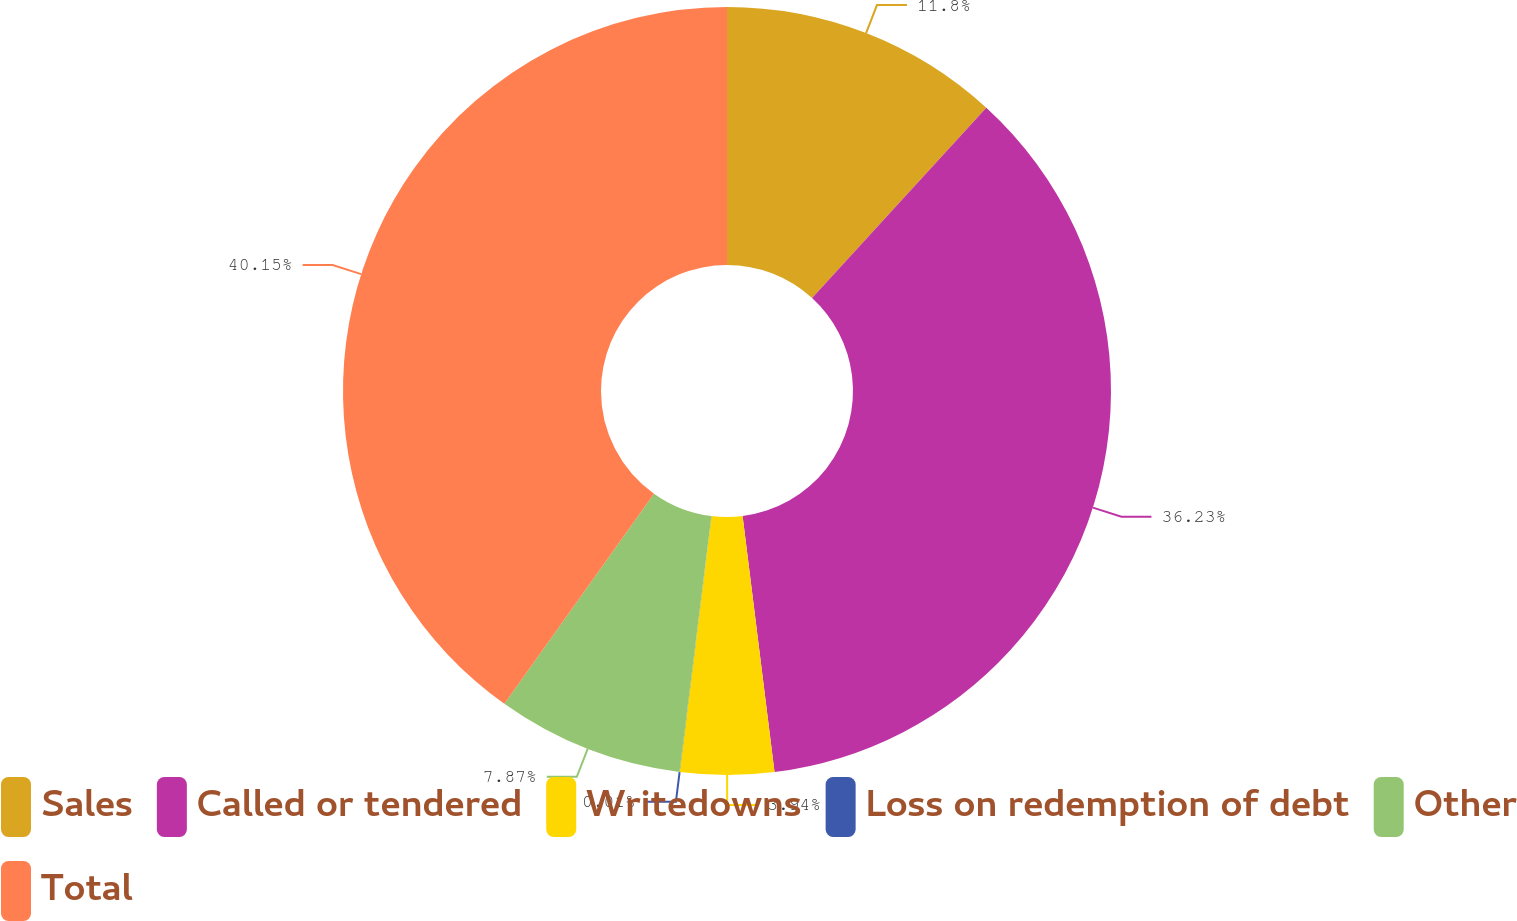Convert chart to OTSL. <chart><loc_0><loc_0><loc_500><loc_500><pie_chart><fcel>Sales<fcel>Called or tendered<fcel>Writedowns<fcel>Loss on redemption of debt<fcel>Other<fcel>Total<nl><fcel>11.8%<fcel>36.23%<fcel>3.94%<fcel>0.01%<fcel>7.87%<fcel>40.16%<nl></chart> 